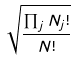Convert formula to latex. <formula><loc_0><loc_0><loc_500><loc_500>\sqrt { \frac { \prod _ { j } N _ { j } ! } { N ! } }</formula> 